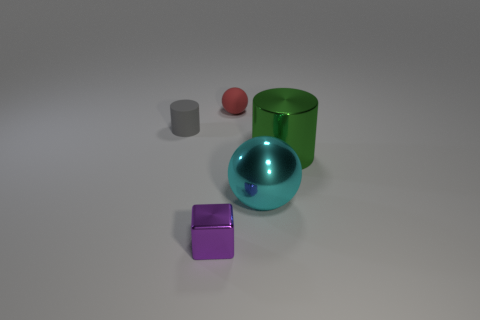Add 1 large cyan metal spheres. How many objects exist? 6 Subtract all cylinders. How many objects are left? 3 Add 3 tiny objects. How many tiny objects are left? 6 Add 2 red matte cylinders. How many red matte cylinders exist? 2 Subtract 1 cyan balls. How many objects are left? 4 Subtract all big brown matte blocks. Subtract all gray rubber cylinders. How many objects are left? 4 